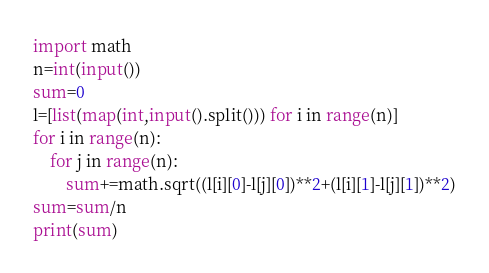<code> <loc_0><loc_0><loc_500><loc_500><_Python_>import math
n=int(input())
sum=0
l=[list(map(int,input().split())) for i in range(n)]
for i in range(n):
    for j in range(n):
        sum+=math.sqrt((l[i][0]-l[j][0])**2+(l[i][1]-l[j][1])**2)
sum=sum/n
print(sum)</code> 